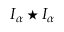Convert formula to latex. <formula><loc_0><loc_0><loc_500><loc_500>I _ { \alpha } ^ { * } I _ { \alpha }</formula> 